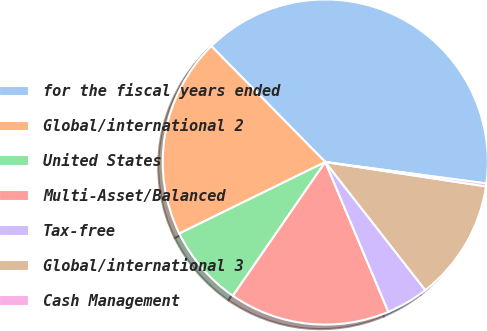Convert chart to OTSL. <chart><loc_0><loc_0><loc_500><loc_500><pie_chart><fcel>for the fiscal years ended<fcel>Global/international 2<fcel>United States<fcel>Multi-Asset/Balanced<fcel>Tax-free<fcel>Global/international 3<fcel>Cash Management<nl><fcel>39.47%<fcel>19.88%<fcel>8.13%<fcel>15.96%<fcel>4.21%<fcel>12.05%<fcel>0.29%<nl></chart> 